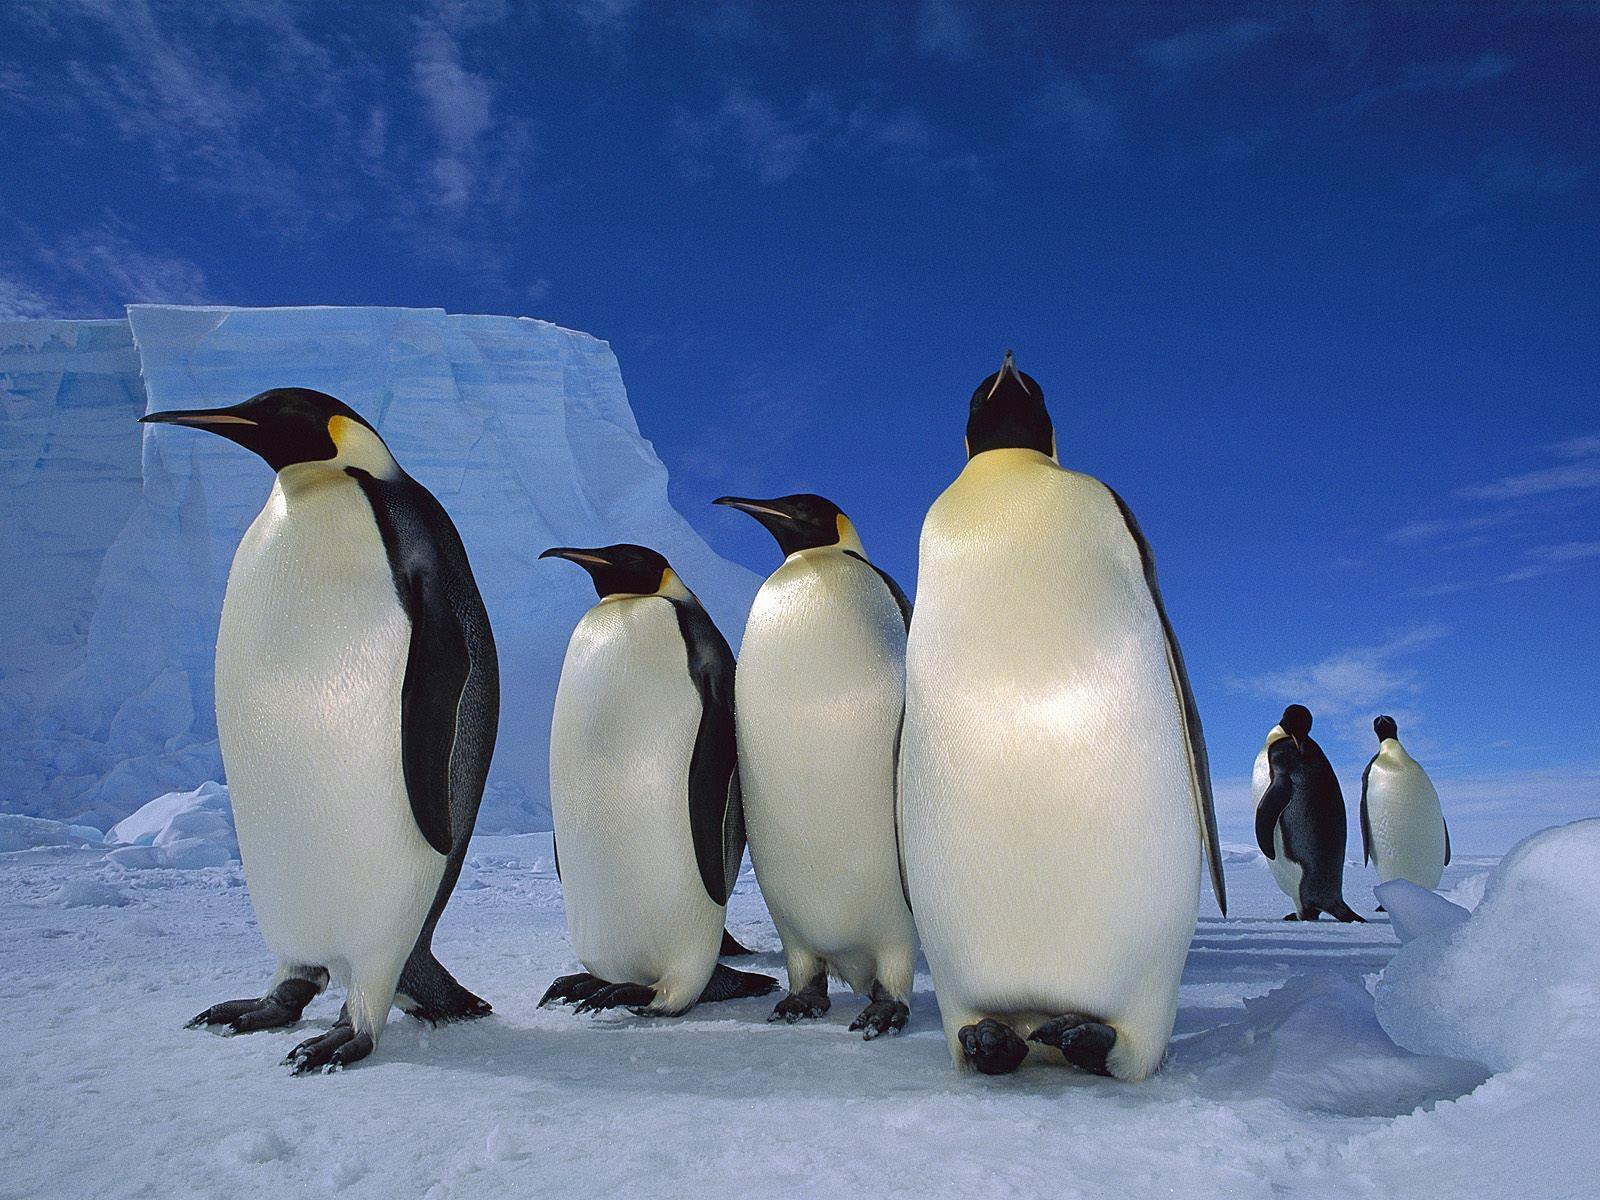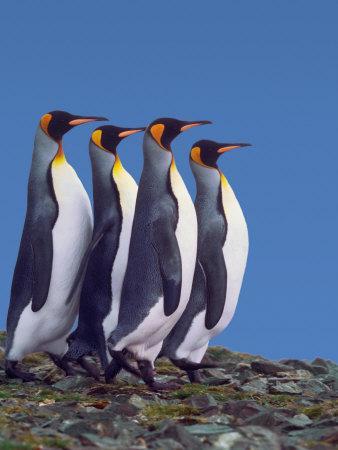The first image is the image on the left, the second image is the image on the right. Evaluate the accuracy of this statement regarding the images: "Both images contain the same number of penguins in the foreground.". Is it true? Answer yes or no. Yes. 